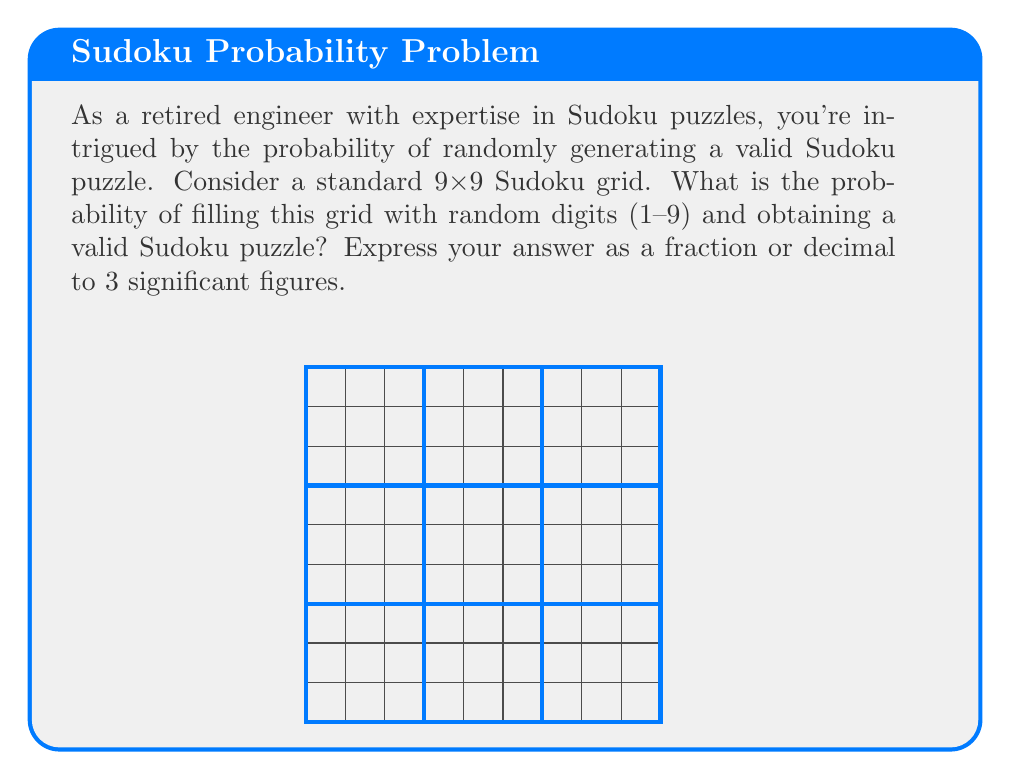Can you answer this question? To solve this problem, let's break it down step-by-step:

1) First, we need to calculate the total number of ways to fill a 9x9 grid with digits 1-9:
   $$9^{81}$$ (81 cells, each with 9 choices)

2) Next, we need to determine the number of valid Sudoku puzzles. This is a complex calculation, but it has been computed:
   $$\text{Number of valid Sudoku grids} \approx 6.67 \times 10^{21}$$

3) The probability is then:

   $$P(\text{valid Sudoku}) = \frac{\text{Number of valid Sudoku grids}}{\text{Total number of possible grids}}$$

   $$= \frac{6.67 \times 10^{21}}{9^{81}}$$

4) Let's calculate this:
   $$9^{81} \approx 1.97 \times 10^{77}$$

   $$\frac{6.67 \times 10^{21}}{1.97 \times 10^{77}} \approx 3.39 \times 10^{-56}$$

5) To three significant figures, this is $3.39 \times 10^{-56}$.

This extremely small probability illustrates why randomly generating a valid Sudoku puzzle is practically impossible, and why proper algorithms are necessary for puzzle generation.
Answer: $3.39 \times 10^{-56}$ 